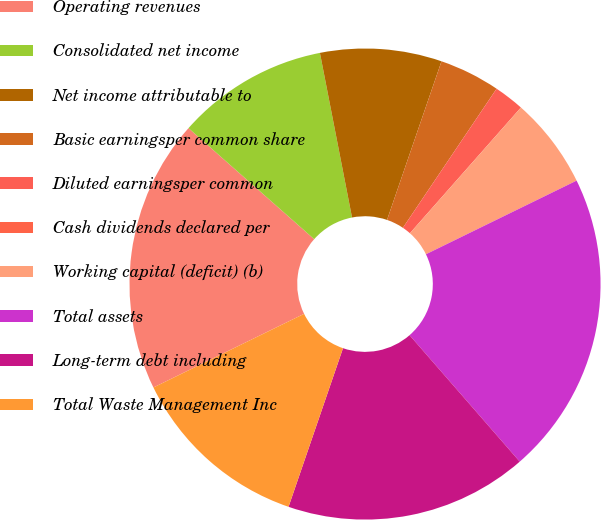Convert chart to OTSL. <chart><loc_0><loc_0><loc_500><loc_500><pie_chart><fcel>Operating revenues<fcel>Consolidated net income<fcel>Net income attributable to<fcel>Basic earningsper common share<fcel>Diluted earningsper common<fcel>Cash dividends declared per<fcel>Working capital (deficit) (b)<fcel>Total assets<fcel>Long-term debt including<fcel>Total Waste Management Inc<nl><fcel>18.75%<fcel>10.42%<fcel>8.33%<fcel>4.17%<fcel>2.08%<fcel>0.0%<fcel>6.25%<fcel>20.83%<fcel>16.67%<fcel>12.5%<nl></chart> 